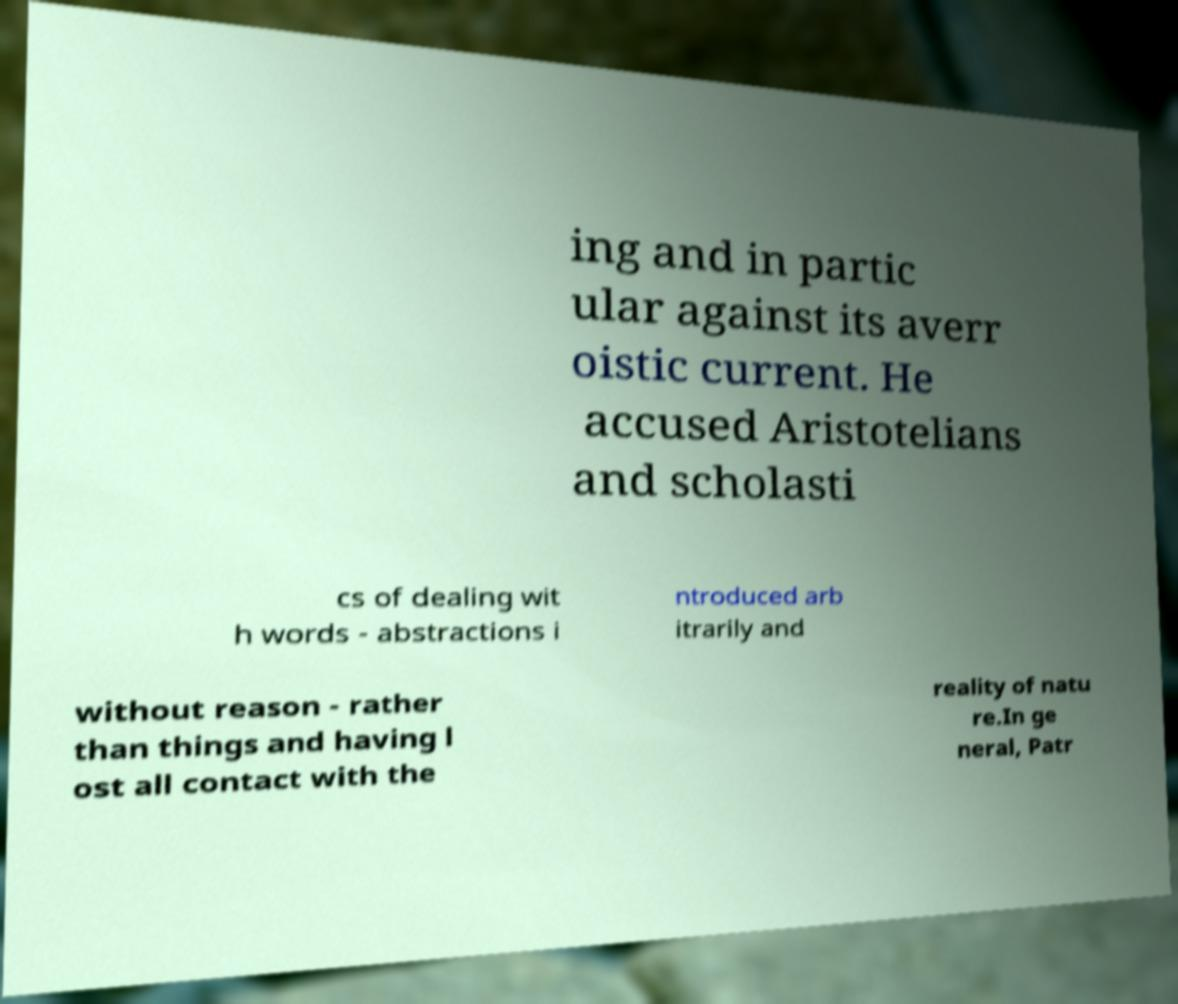Could you assist in decoding the text presented in this image and type it out clearly? ing and in partic ular against its averr oistic current. He accused Aristotelians and scholasti cs of dealing wit h words - abstractions i ntroduced arb itrarily and without reason - rather than things and having l ost all contact with the reality of natu re.In ge neral, Patr 